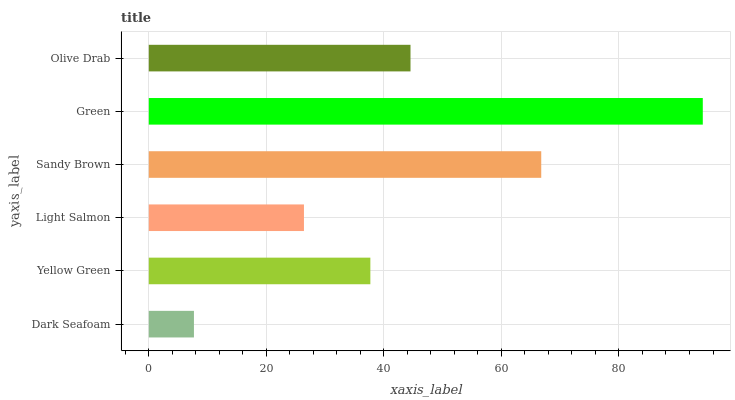Is Dark Seafoam the minimum?
Answer yes or no. Yes. Is Green the maximum?
Answer yes or no. Yes. Is Yellow Green the minimum?
Answer yes or no. No. Is Yellow Green the maximum?
Answer yes or no. No. Is Yellow Green greater than Dark Seafoam?
Answer yes or no. Yes. Is Dark Seafoam less than Yellow Green?
Answer yes or no. Yes. Is Dark Seafoam greater than Yellow Green?
Answer yes or no. No. Is Yellow Green less than Dark Seafoam?
Answer yes or no. No. Is Olive Drab the high median?
Answer yes or no. Yes. Is Yellow Green the low median?
Answer yes or no. Yes. Is Green the high median?
Answer yes or no. No. Is Sandy Brown the low median?
Answer yes or no. No. 